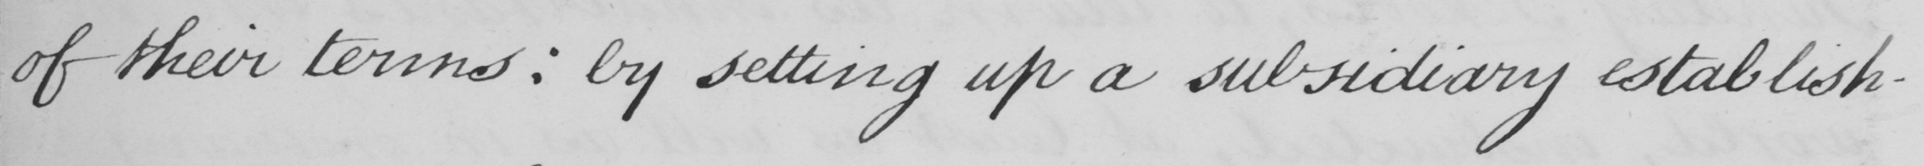Can you read and transcribe this handwriting? of their terms :  by setting up a subsidiary establish- 